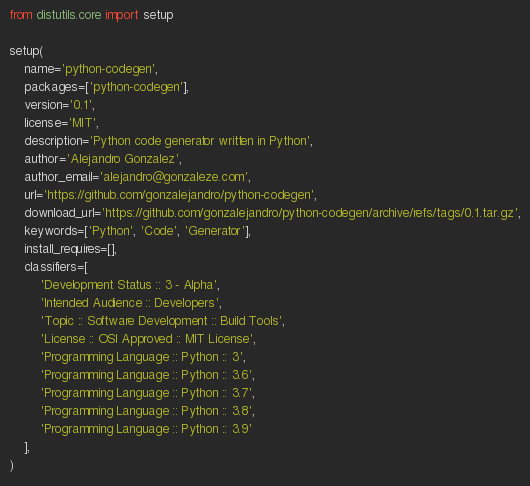Convert code to text. <code><loc_0><loc_0><loc_500><loc_500><_Python_>from distutils.core import setup

setup(
    name='python-codegen',
    packages=['python-codegen'],
    version='0.1',
    license='MIT',
    description='Python code generator written in Python',
    author='Alejandro Gonzalez',
    author_email='alejandro@gonzaleze.com',
    url='https://github.com/gonzalejandro/python-codegen',
    download_url='https://github.com/gonzalejandro/python-codegen/archive/refs/tags/0.1.tar.gz',
    keywords=['Python', 'Code', 'Generator'],
    install_requires=[],
    classifiers=[
        'Development Status :: 3 - Alpha',
        'Intended Audience :: Developers',
        'Topic :: Software Development :: Build Tools',
        'License :: OSI Approved :: MIT License',
        'Programming Language :: Python :: 3',
        'Programming Language :: Python :: 3.6',
        'Programming Language :: Python :: 3.7',
        'Programming Language :: Python :: 3.8',
        'Programming Language :: Python :: 3.9'
    ],
)
</code> 